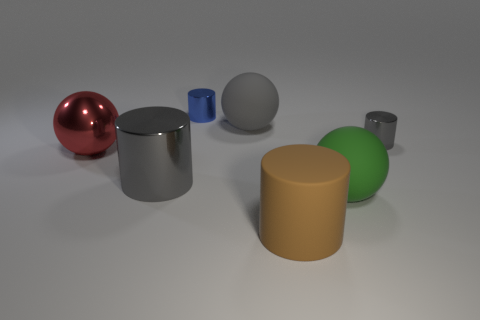Is the gray object that is to the left of the blue cylinder made of the same material as the ball on the right side of the gray matte thing?
Provide a succinct answer. No. There is a blue cylinder that is made of the same material as the small gray object; what is its size?
Provide a succinct answer. Small. What is the shape of the matte thing left of the large brown rubber object?
Give a very brief answer. Sphere. There is a big metal object that is in front of the red metal sphere; does it have the same color as the ball that is in front of the red metal thing?
Your answer should be compact. No. There is a rubber thing that is the same color as the large metallic cylinder; what is its size?
Give a very brief answer. Large. Are there any big objects?
Your answer should be very brief. Yes. The gray metallic thing behind the gray shiny cylinder on the left side of the gray metal cylinder behind the big gray metallic thing is what shape?
Your answer should be very brief. Cylinder. What number of gray cylinders are in front of the small gray metal object?
Offer a terse response. 1. Do the small thing that is to the left of the brown cylinder and the tiny gray cylinder have the same material?
Keep it short and to the point. Yes. What number of other things are the same shape as the small gray object?
Provide a succinct answer. 3. 